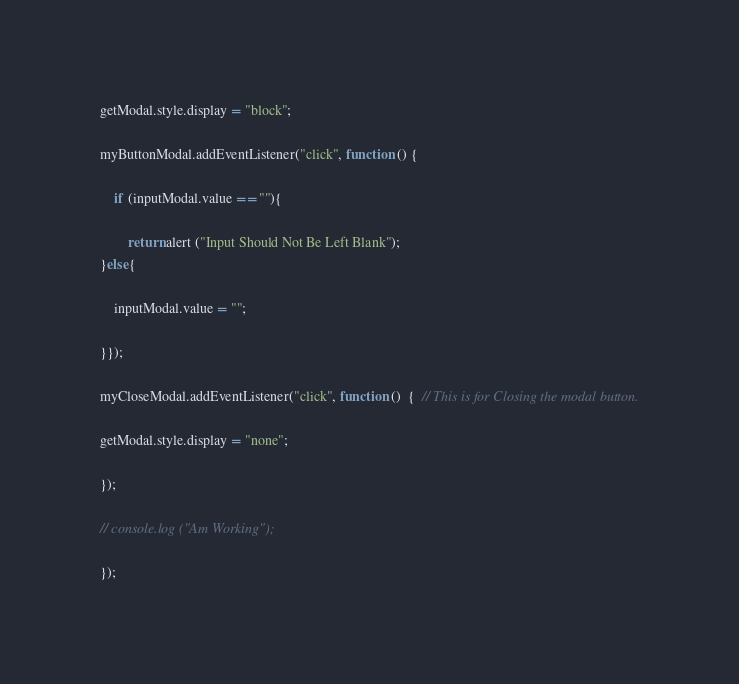<code> <loc_0><loc_0><loc_500><loc_500><_JavaScript_>

getModal.style.display = "block";

myButtonModal.addEventListener("click", function () {
 
    if (inputModal.value == ""){

        return alert ("Input Should Not Be Left Blank");
}else{
    
    inputModal.value = "";
    
}});

myCloseModal.addEventListener("click", function ()  {  // This is for Closing the modal button.
    
getModal.style.display = "none";

});

// console.log ("Am Working");

});

</code> 